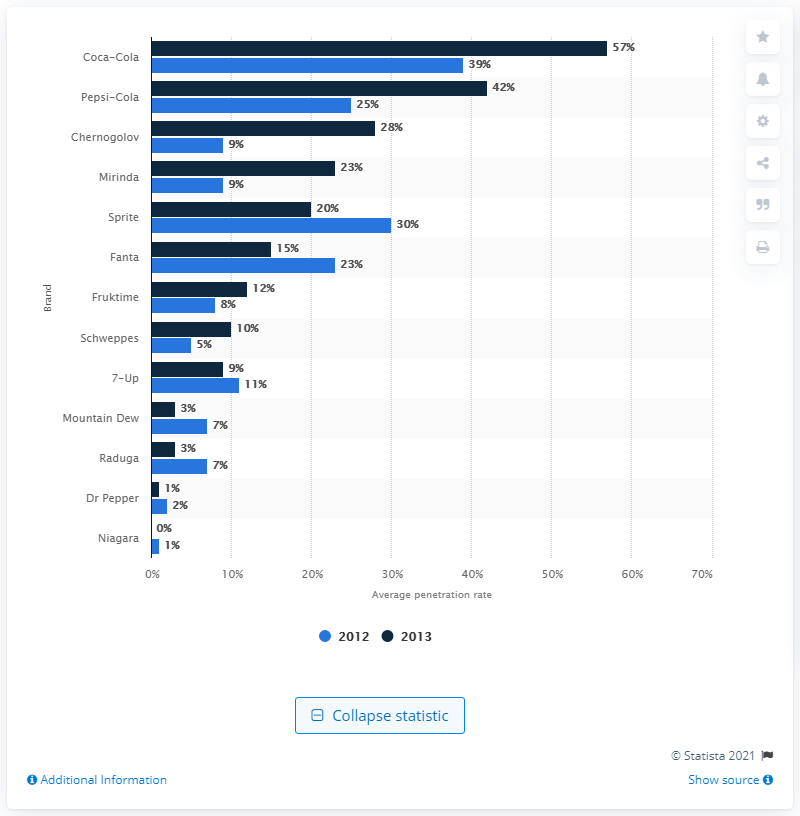Give some essential details in this illustration. In a survey conducted in 2013, 23% of respondents reported purchasing Mirinda, a brand of soft drink, in the last three to twelve months. 